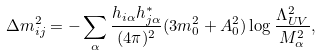<formula> <loc_0><loc_0><loc_500><loc_500>\Delta m ^ { 2 } _ { i j } = - \sum _ { \alpha } \frac { h _ { i \alpha } h _ { j \alpha } ^ { * } } { ( 4 \pi ) ^ { 2 } } ( 3 m _ { 0 } ^ { 2 } + A _ { 0 } ^ { 2 } ) \log \frac { \Lambda _ { U V } ^ { 2 } } { M _ { \alpha } ^ { 2 } } ,</formula> 